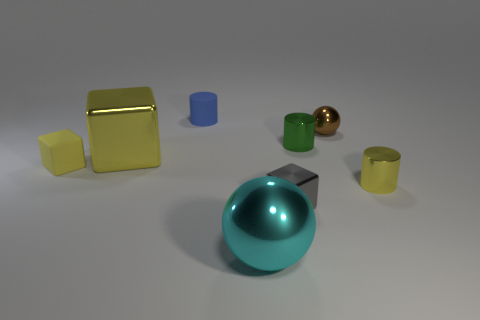Subtract all green spheres. Subtract all red cylinders. How many spheres are left? 2 Add 2 tiny shiny balls. How many objects exist? 10 Subtract all cubes. How many objects are left? 5 Add 6 cyan cylinders. How many cyan cylinders exist? 6 Subtract 1 brown spheres. How many objects are left? 7 Subtract all tiny purple blocks. Subtract all yellow things. How many objects are left? 5 Add 5 yellow things. How many yellow things are left? 8 